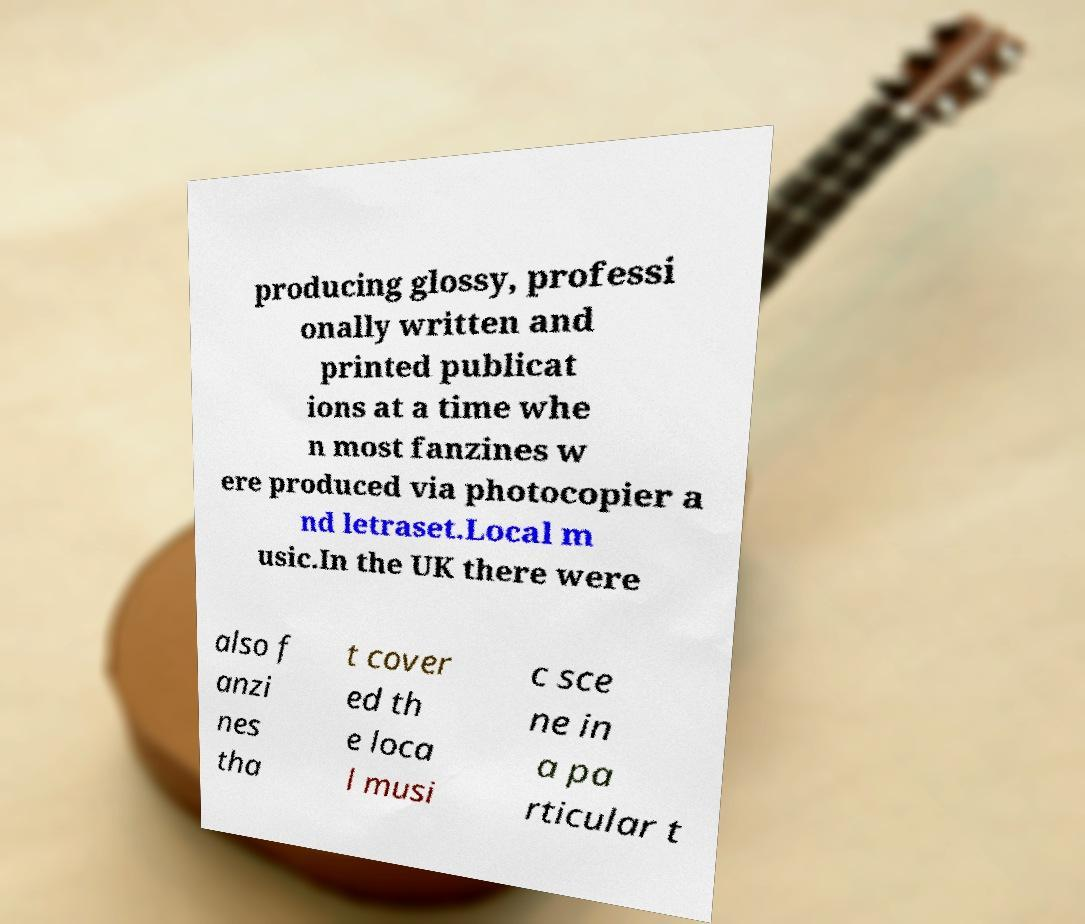Please identify and transcribe the text found in this image. producing glossy, professi onally written and printed publicat ions at a time whe n most fanzines w ere produced via photocopier a nd letraset.Local m usic.In the UK there were also f anzi nes tha t cover ed th e loca l musi c sce ne in a pa rticular t 